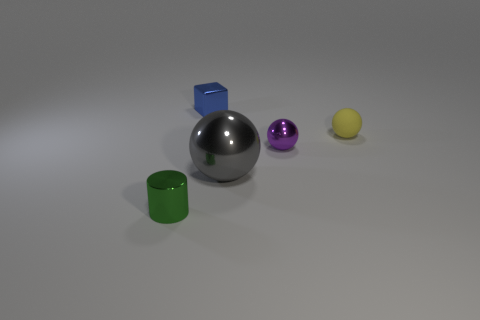There is a purple object that is the same shape as the gray metal thing; what material is it?
Give a very brief answer. Metal. Is the number of big things less than the number of objects?
Make the answer very short. Yes. The big thing that is the same material as the cube is what color?
Provide a short and direct response. Gray. Do the metallic cylinder and the purple shiny thing have the same size?
Offer a terse response. Yes. What material is the yellow thing?
Offer a terse response. Rubber. There is a yellow ball that is the same size as the blue cube; what is it made of?
Give a very brief answer. Rubber. Are there any other metal objects that have the same size as the purple metallic thing?
Ensure brevity in your answer.  Yes. Are there the same number of gray shiny balls that are to the right of the rubber ball and balls that are to the right of the tiny green object?
Provide a short and direct response. No. Are there more matte balls than objects?
Offer a terse response. No. What number of shiny objects are blue blocks or large cyan objects?
Keep it short and to the point. 1. 